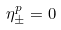<formula> <loc_0><loc_0><loc_500><loc_500>\eta _ { \pm } ^ { p } = 0</formula> 